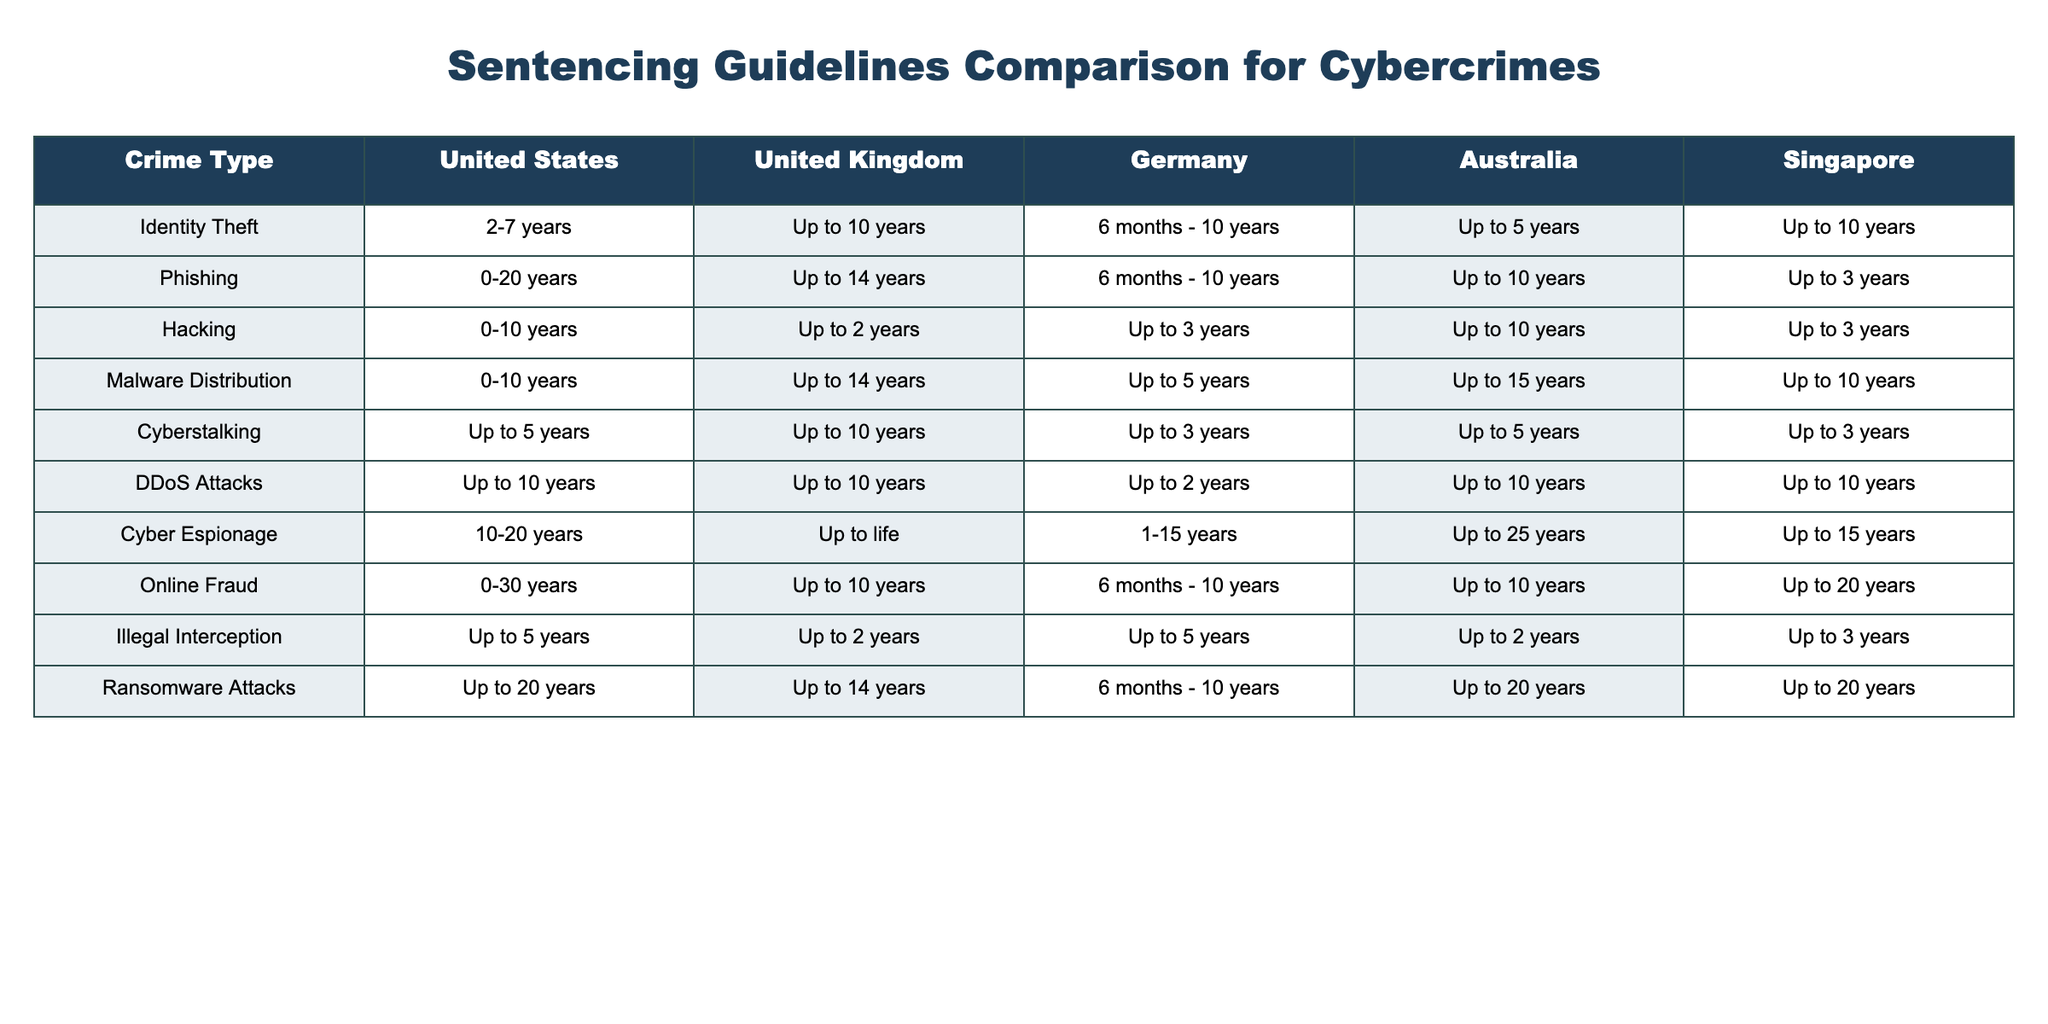What is the maximum sentence for Phishing in the United States? The table indicates that the maximum sentence for Phishing in the United States is 20 years.
Answer: 20 years How does the maximum sentence for Identity Theft in Australia compare to that in Germany? In Australia, the maximum sentence for Identity Theft is up to 5 years, while in Germany it is ranged from 6 months to 10 years. Since 10 years is the maximum and 5 years is not more than that, Australia's maximum is less than Germany's.
Answer: Australia has a lower maximum sentence Which jurisdiction has the highest maximum sentence for Cyber Espionage? Looking at the table, the United Kingdom has the highest maximum sentence for Cyber Espionage, which is up to life.
Answer: United Kingdom What is the difference in maximum sentences for DDoS Attacks between the United States and Germany? The maximum sentence for DDoS Attacks in the United States is up to 10 years, while in Germany it is up to 2 years. To find the difference, subtract 2 from 10, which equals 8 years.
Answer: 8 years Is the maximum sentence for Malware Distribution equal in the United Kingdom and Singapore? According to the table, the maximum sentence for Malware Distribution is up to 14 years in the United Kingdom and up to 10 years in Singapore, which means they are not equal.
Answer: No 